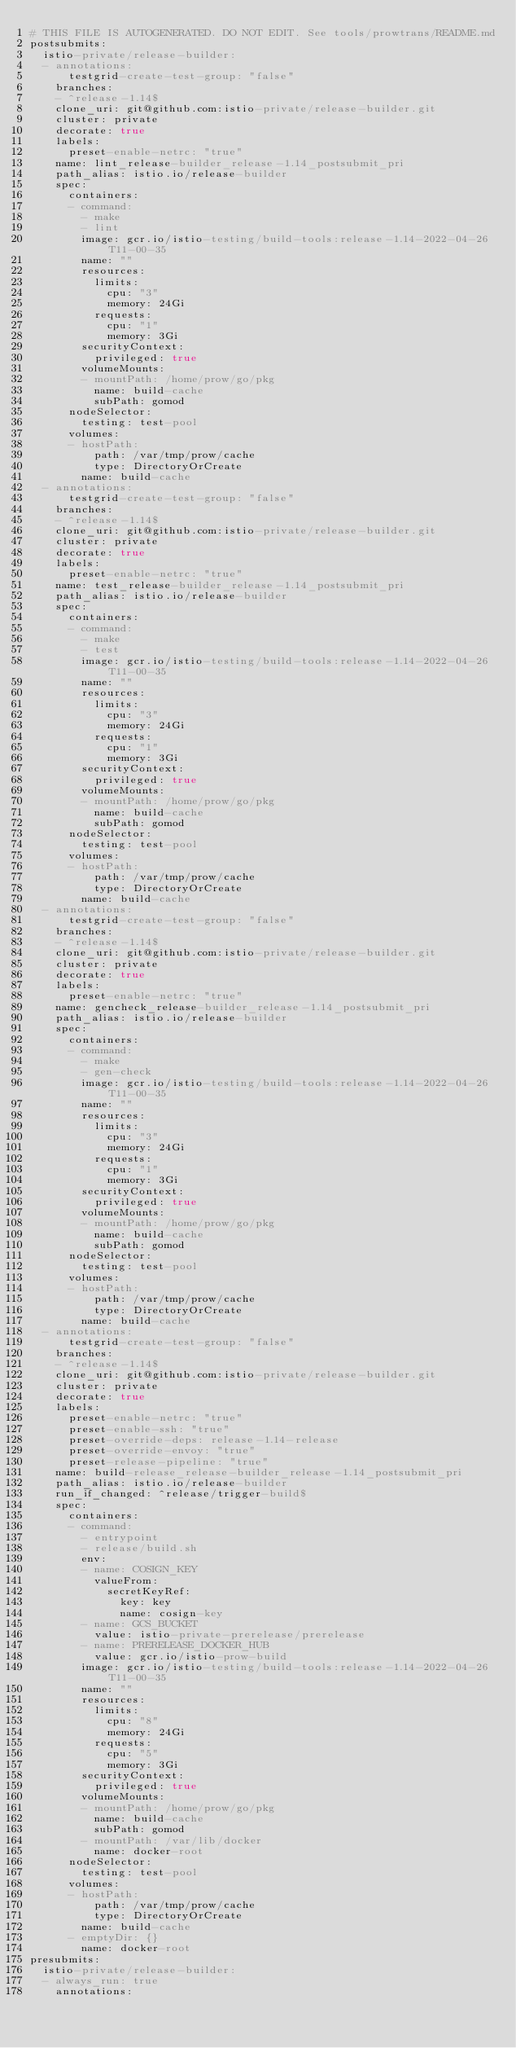<code> <loc_0><loc_0><loc_500><loc_500><_YAML_># THIS FILE IS AUTOGENERATED. DO NOT EDIT. See tools/prowtrans/README.md
postsubmits:
  istio-private/release-builder:
  - annotations:
      testgrid-create-test-group: "false"
    branches:
    - ^release-1.14$
    clone_uri: git@github.com:istio-private/release-builder.git
    cluster: private
    decorate: true
    labels:
      preset-enable-netrc: "true"
    name: lint_release-builder_release-1.14_postsubmit_pri
    path_alias: istio.io/release-builder
    spec:
      containers:
      - command:
        - make
        - lint
        image: gcr.io/istio-testing/build-tools:release-1.14-2022-04-26T11-00-35
        name: ""
        resources:
          limits:
            cpu: "3"
            memory: 24Gi
          requests:
            cpu: "1"
            memory: 3Gi
        securityContext:
          privileged: true
        volumeMounts:
        - mountPath: /home/prow/go/pkg
          name: build-cache
          subPath: gomod
      nodeSelector:
        testing: test-pool
      volumes:
      - hostPath:
          path: /var/tmp/prow/cache
          type: DirectoryOrCreate
        name: build-cache
  - annotations:
      testgrid-create-test-group: "false"
    branches:
    - ^release-1.14$
    clone_uri: git@github.com:istio-private/release-builder.git
    cluster: private
    decorate: true
    labels:
      preset-enable-netrc: "true"
    name: test_release-builder_release-1.14_postsubmit_pri
    path_alias: istio.io/release-builder
    spec:
      containers:
      - command:
        - make
        - test
        image: gcr.io/istio-testing/build-tools:release-1.14-2022-04-26T11-00-35
        name: ""
        resources:
          limits:
            cpu: "3"
            memory: 24Gi
          requests:
            cpu: "1"
            memory: 3Gi
        securityContext:
          privileged: true
        volumeMounts:
        - mountPath: /home/prow/go/pkg
          name: build-cache
          subPath: gomod
      nodeSelector:
        testing: test-pool
      volumes:
      - hostPath:
          path: /var/tmp/prow/cache
          type: DirectoryOrCreate
        name: build-cache
  - annotations:
      testgrid-create-test-group: "false"
    branches:
    - ^release-1.14$
    clone_uri: git@github.com:istio-private/release-builder.git
    cluster: private
    decorate: true
    labels:
      preset-enable-netrc: "true"
    name: gencheck_release-builder_release-1.14_postsubmit_pri
    path_alias: istio.io/release-builder
    spec:
      containers:
      - command:
        - make
        - gen-check
        image: gcr.io/istio-testing/build-tools:release-1.14-2022-04-26T11-00-35
        name: ""
        resources:
          limits:
            cpu: "3"
            memory: 24Gi
          requests:
            cpu: "1"
            memory: 3Gi
        securityContext:
          privileged: true
        volumeMounts:
        - mountPath: /home/prow/go/pkg
          name: build-cache
          subPath: gomod
      nodeSelector:
        testing: test-pool
      volumes:
      - hostPath:
          path: /var/tmp/prow/cache
          type: DirectoryOrCreate
        name: build-cache
  - annotations:
      testgrid-create-test-group: "false"
    branches:
    - ^release-1.14$
    clone_uri: git@github.com:istio-private/release-builder.git
    cluster: private
    decorate: true
    labels:
      preset-enable-netrc: "true"
      preset-enable-ssh: "true"
      preset-override-deps: release-1.14-release
      preset-override-envoy: "true"
      preset-release-pipeline: "true"
    name: build-release_release-builder_release-1.14_postsubmit_pri
    path_alias: istio.io/release-builder
    run_if_changed: ^release/trigger-build$
    spec:
      containers:
      - command:
        - entrypoint
        - release/build.sh
        env:
        - name: COSIGN_KEY
          valueFrom:
            secretKeyRef:
              key: key
              name: cosign-key
        - name: GCS_BUCKET
          value: istio-private-prerelease/prerelease
        - name: PRERELEASE_DOCKER_HUB
          value: gcr.io/istio-prow-build
        image: gcr.io/istio-testing/build-tools:release-1.14-2022-04-26T11-00-35
        name: ""
        resources:
          limits:
            cpu: "8"
            memory: 24Gi
          requests:
            cpu: "5"
            memory: 3Gi
        securityContext:
          privileged: true
        volumeMounts:
        - mountPath: /home/prow/go/pkg
          name: build-cache
          subPath: gomod
        - mountPath: /var/lib/docker
          name: docker-root
      nodeSelector:
        testing: test-pool
      volumes:
      - hostPath:
          path: /var/tmp/prow/cache
          type: DirectoryOrCreate
        name: build-cache
      - emptyDir: {}
        name: docker-root
presubmits:
  istio-private/release-builder:
  - always_run: true
    annotations:</code> 